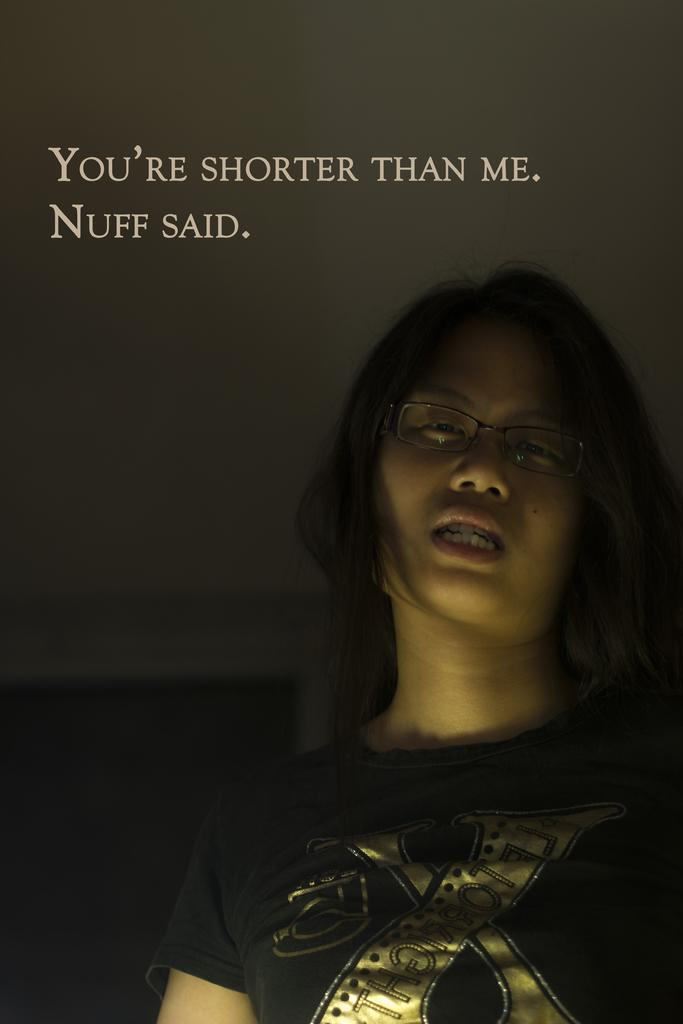Who is the main subject in the image? There is a lady in the image. What accessory is the lady wearing? The lady is wearing spectacles. What else can be seen at the top of the image? There is text visible at the top of the image. How many giants are present in the image? There are no giants present in the image. What type of form does the rain take in the image? There is no rain present in the image. 